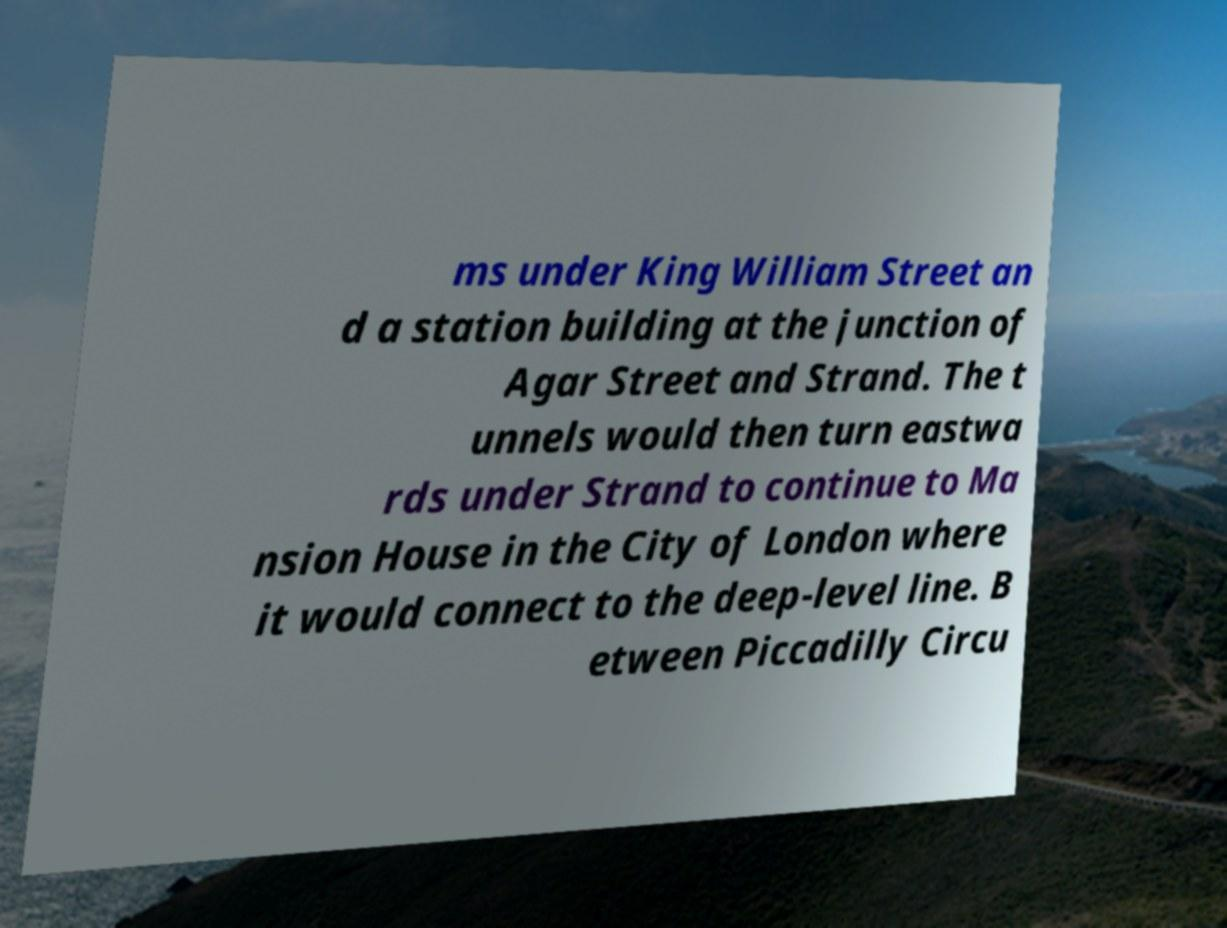There's text embedded in this image that I need extracted. Can you transcribe it verbatim? ms under King William Street an d a station building at the junction of Agar Street and Strand. The t unnels would then turn eastwa rds under Strand to continue to Ma nsion House in the City of London where it would connect to the deep-level line. B etween Piccadilly Circu 